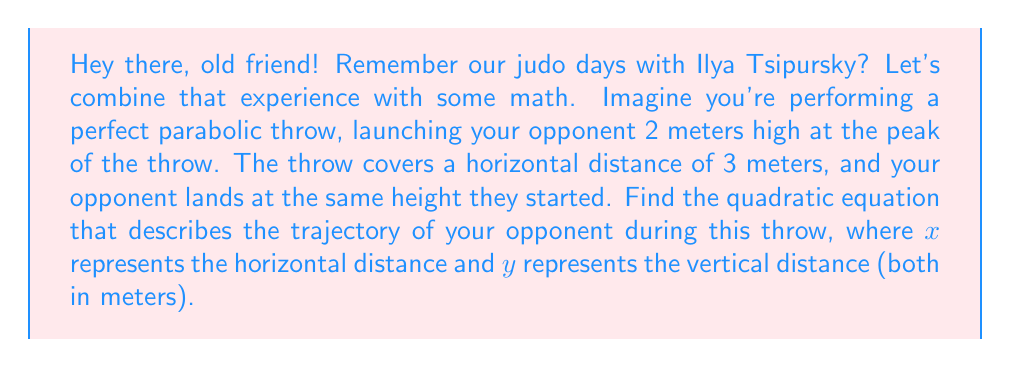Help me with this question. Let's approach this step-by-step:

1) The general form of a quadratic equation is $y = ax^2 + bx + c$, where $a$, $b$, and $c$ are constants.

2) We know three points on this parabola:
   - Start: (0, 0)
   - Peak: (1.5, 2)
   - End: (3, 0)

3) Let's use these points to set up a system of equations:
   
   $0 = a(0)^2 + b(0) + c$
   $2 = a(1.5)^2 + b(1.5) + c$
   $0 = a(3)^2 + b(3) + c$

4) From the first equation, we can deduce that $c = 0$.

5) Now we have two equations:
   
   $2 = 2.25a + 1.5b$
   $0 = 9a + 3b$

6) From the second equation: $b = -3a$

7) Substituting this into the first equation:
   
   $2 = 2.25a + 1.5(-3a)$
   $2 = 2.25a - 4.5a$
   $2 = -2.25a$
   $a = -\frac{8}{9}$

8) Now we can find $b$:
   $b = -3(-\frac{8}{9}) = \frac{8}{3}$

9) Therefore, the quadratic equation is:

   $y = -\frac{8}{9}x^2 + \frac{8}{3}x$
Answer: $y = -\frac{8}{9}x^2 + \frac{8}{3}x$ 